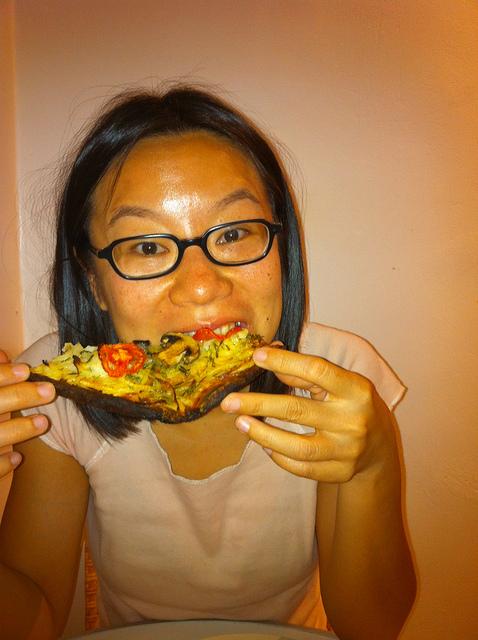What is this woman's probable nationality?
Write a very short answer. Asian. Is the woman smiling or eating?
Short answer required. Eating. Is there mushroom on the pizza?
Concise answer only. Yes. 